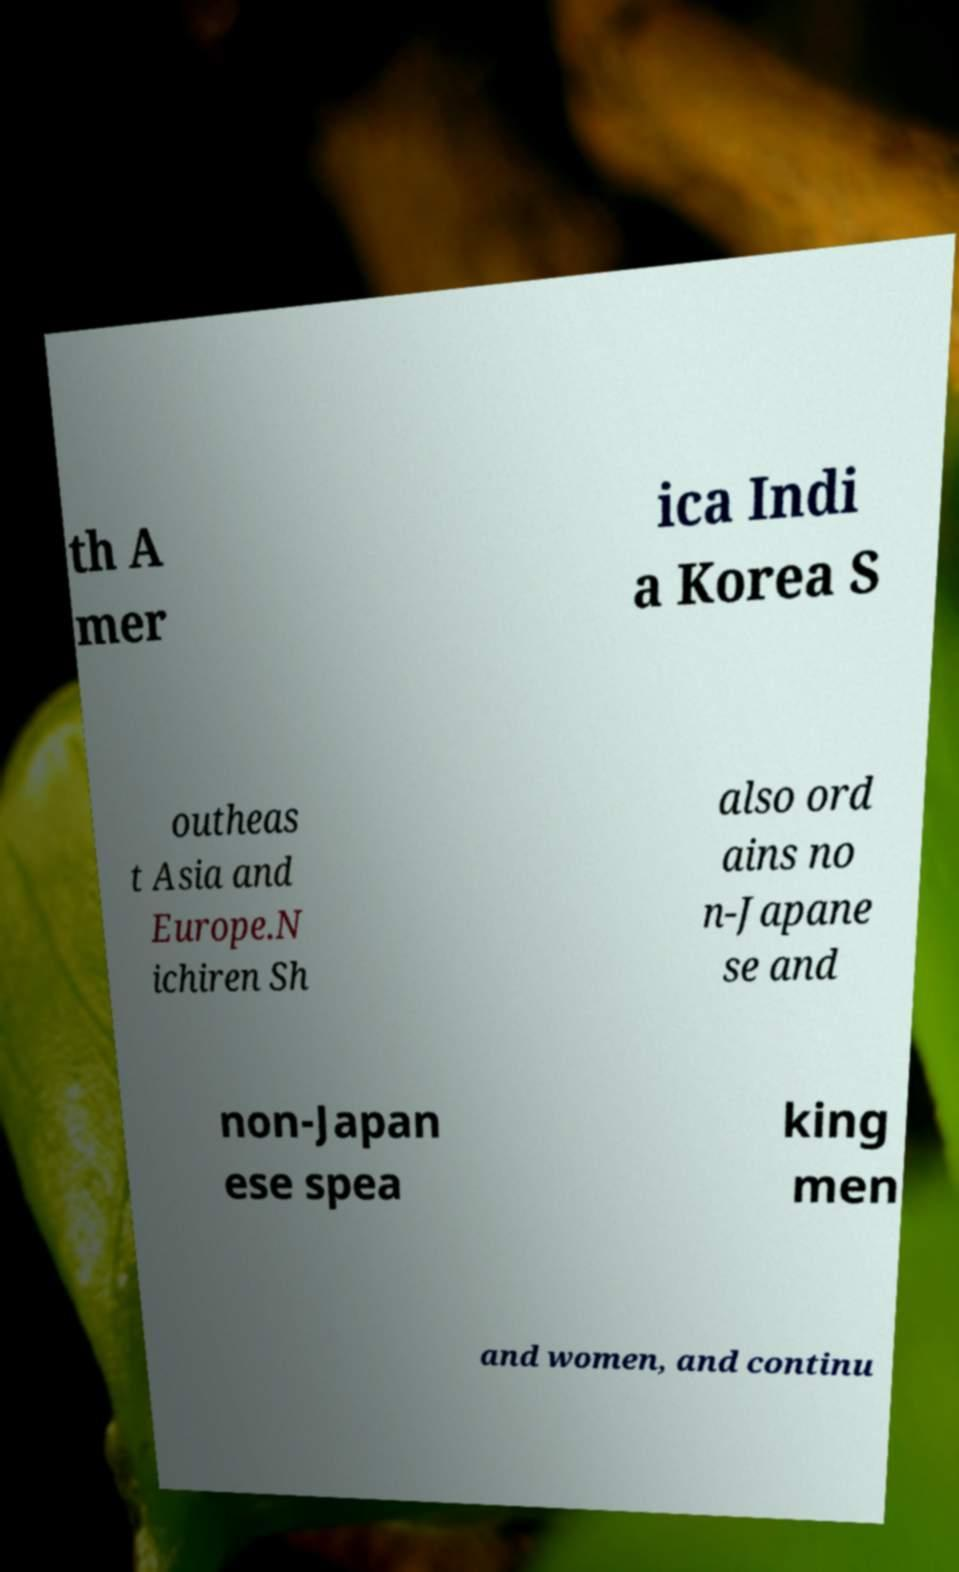Please read and relay the text visible in this image. What does it say? th A mer ica Indi a Korea S outheas t Asia and Europe.N ichiren Sh also ord ains no n-Japane se and non-Japan ese spea king men and women, and continu 